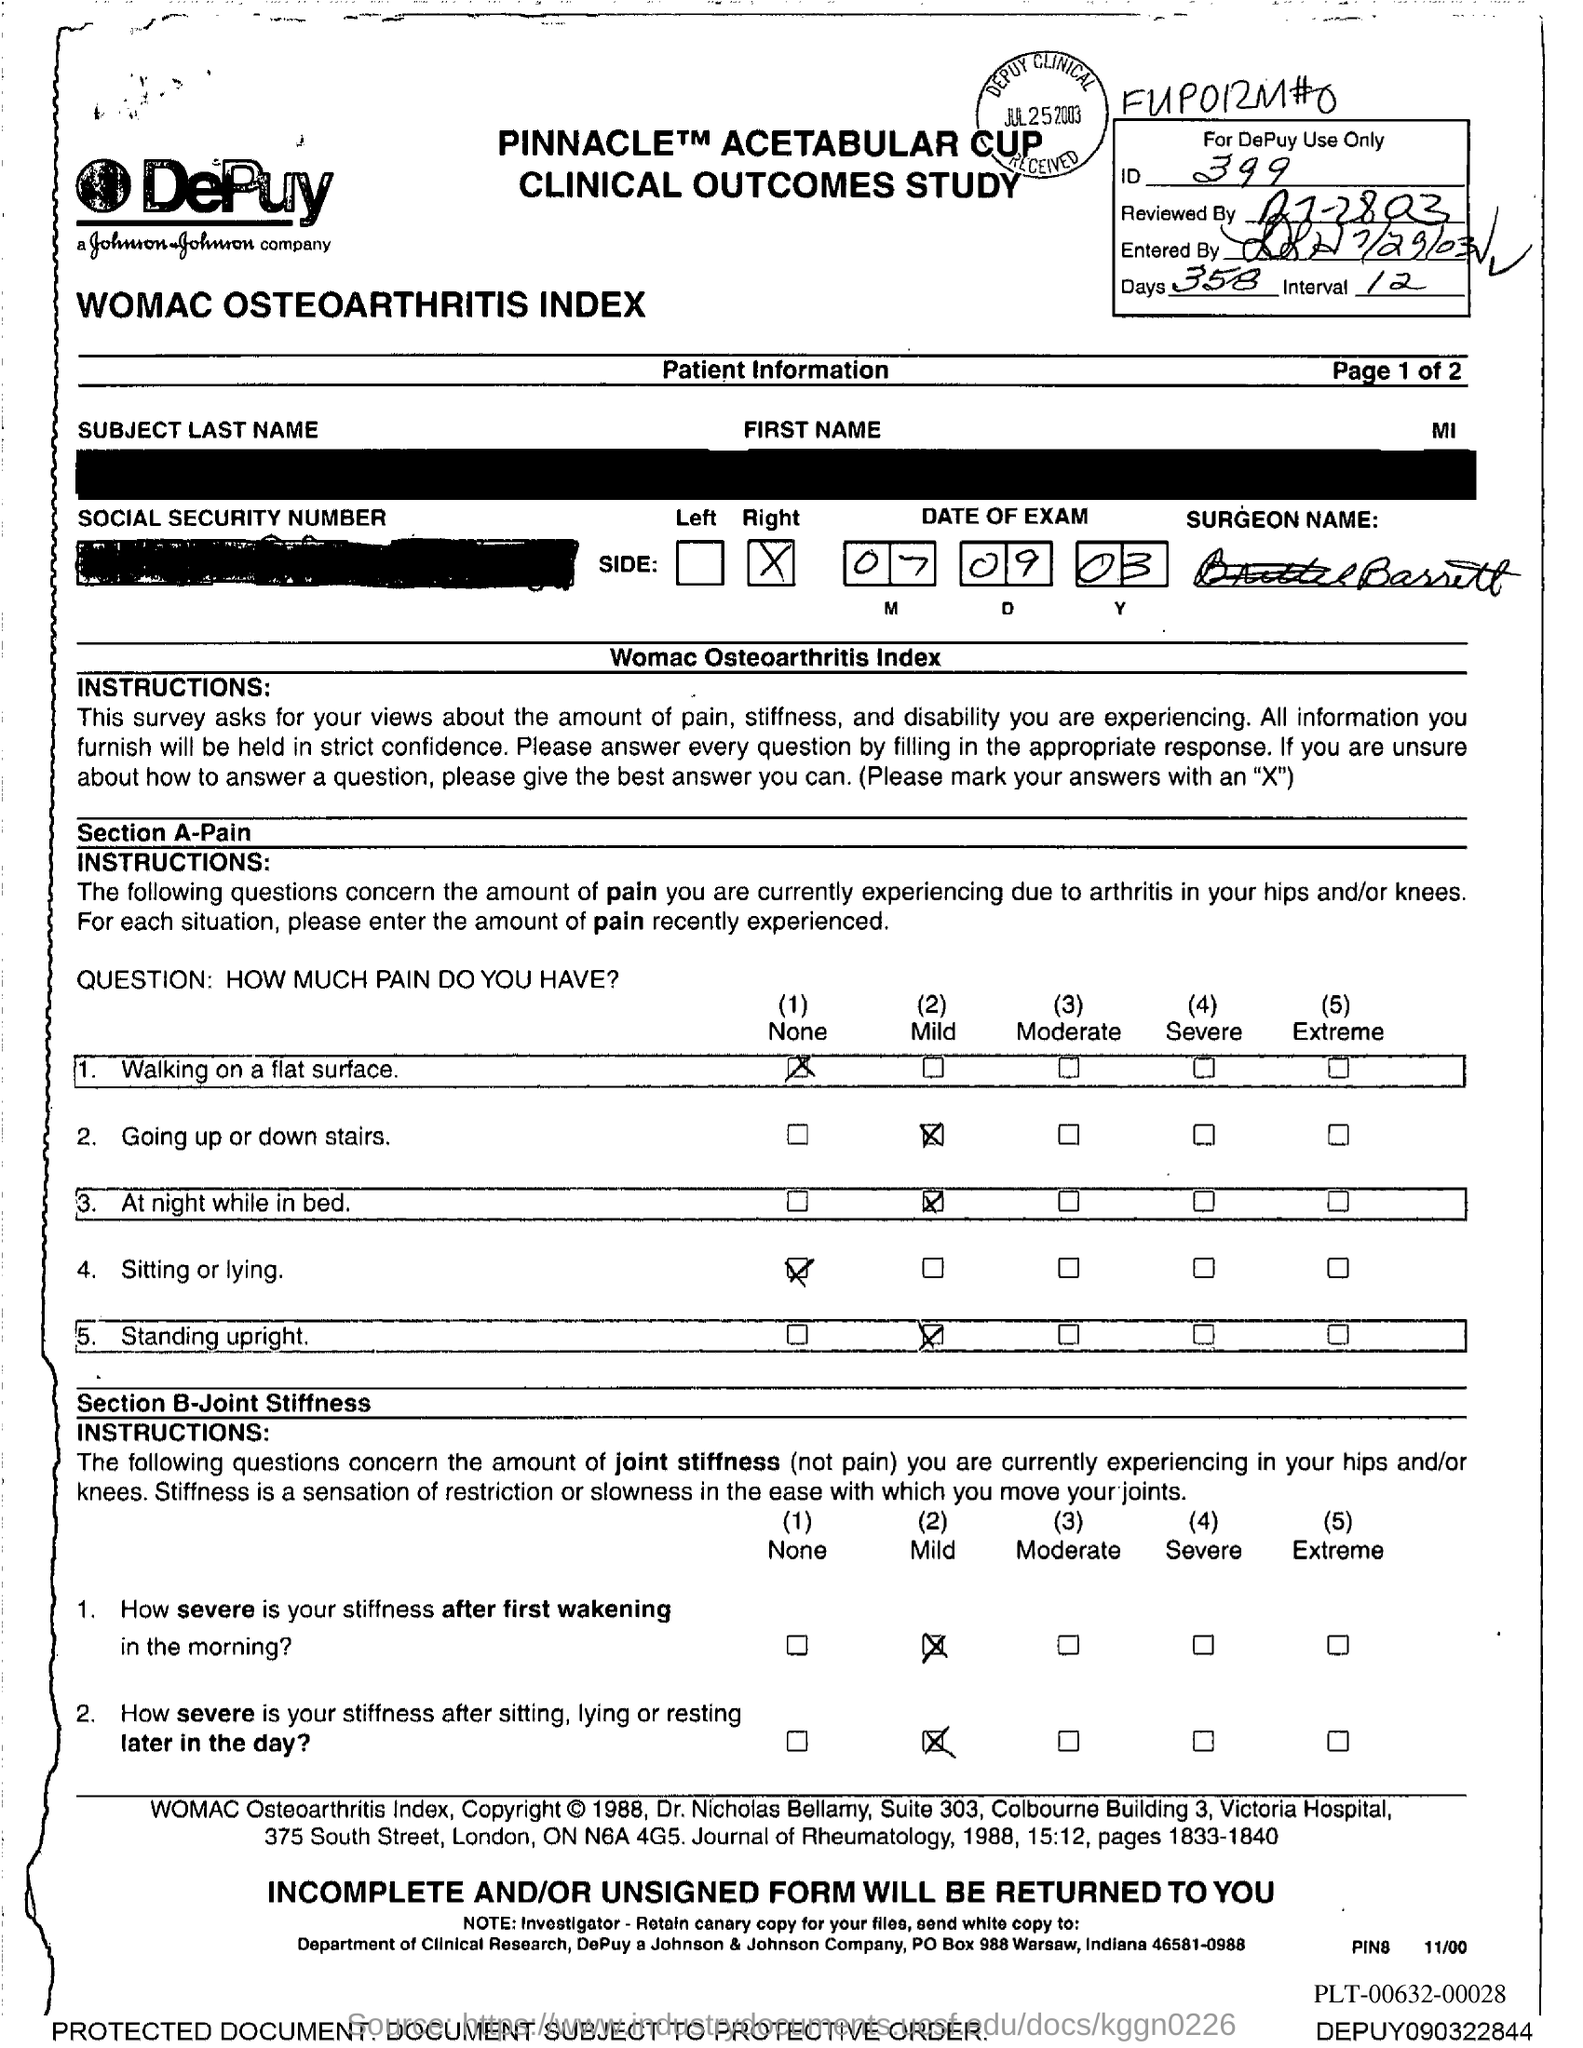Point out several critical features in this image. There are 358 days given in the form. The surgeon's name mentioned in the form is Barrett. The ID mentioned in the form is 399. The interval period mentioned in the form is 12.. The date of the exam mentioned in the form is September 7, 2003. 